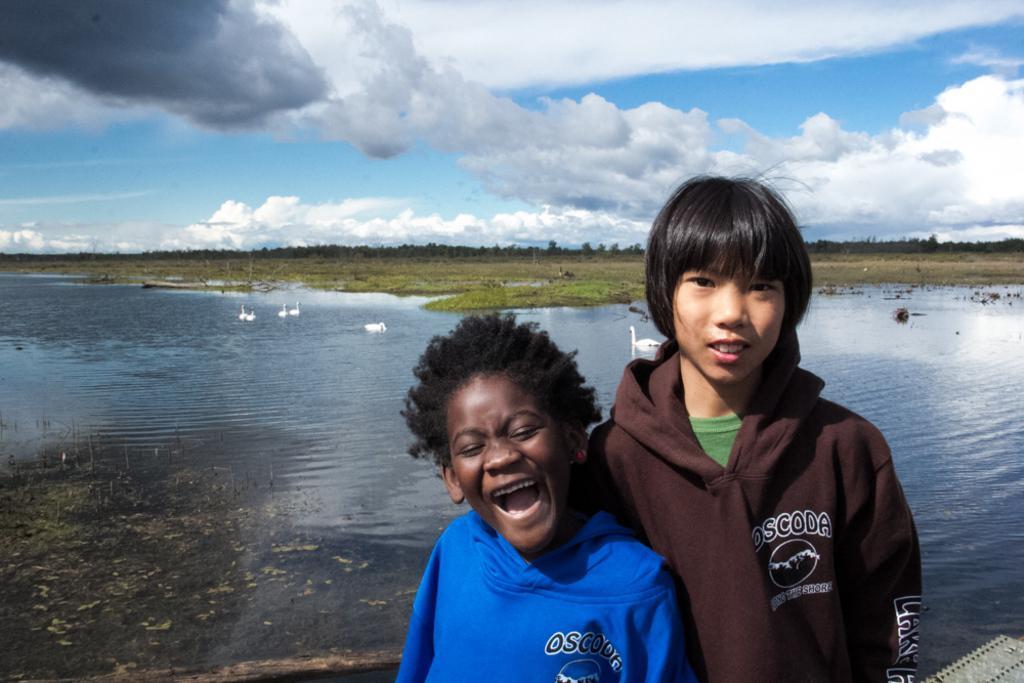In one or two sentences, can you explain what this image depicts? In the image we can see two children wearing clothes. Here we can see water, birds in the water, grass, trees and the cloudy sky. 